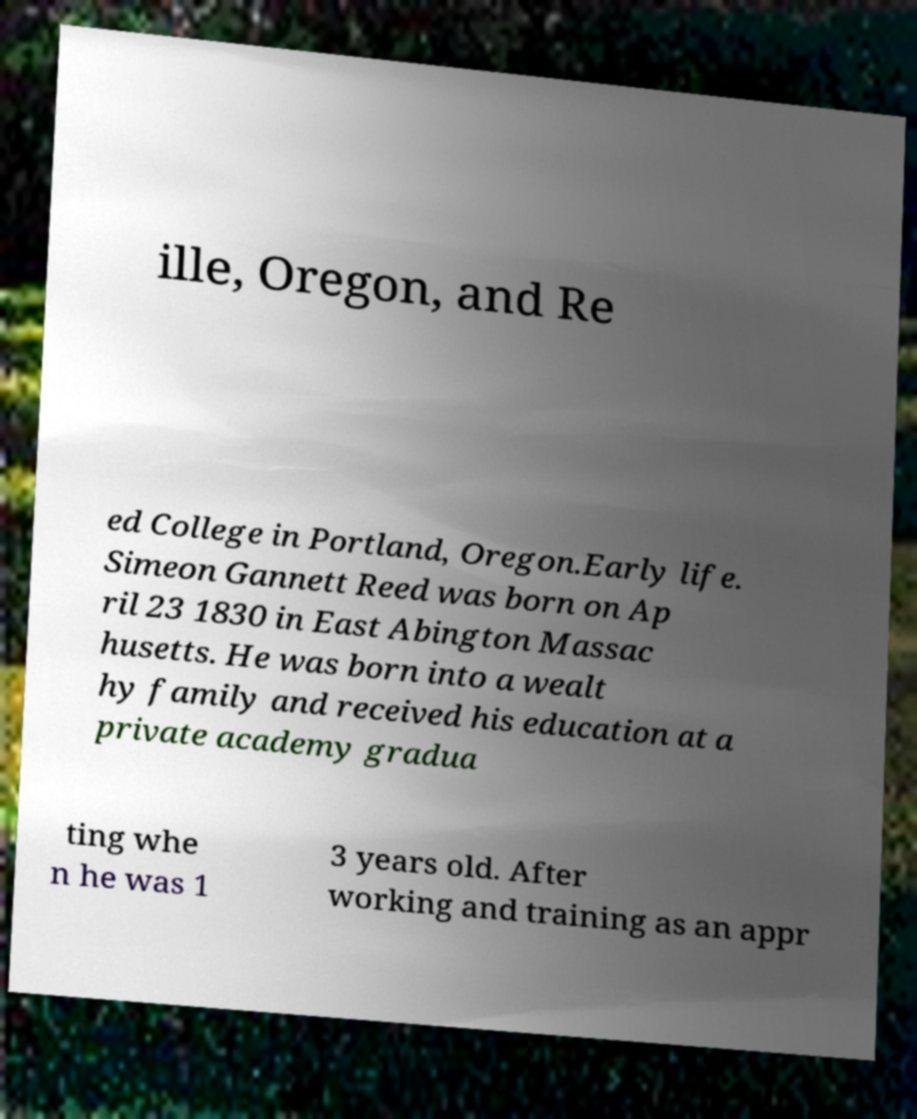What messages or text are displayed in this image? I need them in a readable, typed format. ille, Oregon, and Re ed College in Portland, Oregon.Early life. Simeon Gannett Reed was born on Ap ril 23 1830 in East Abington Massac husetts. He was born into a wealt hy family and received his education at a private academy gradua ting whe n he was 1 3 years old. After working and training as an appr 